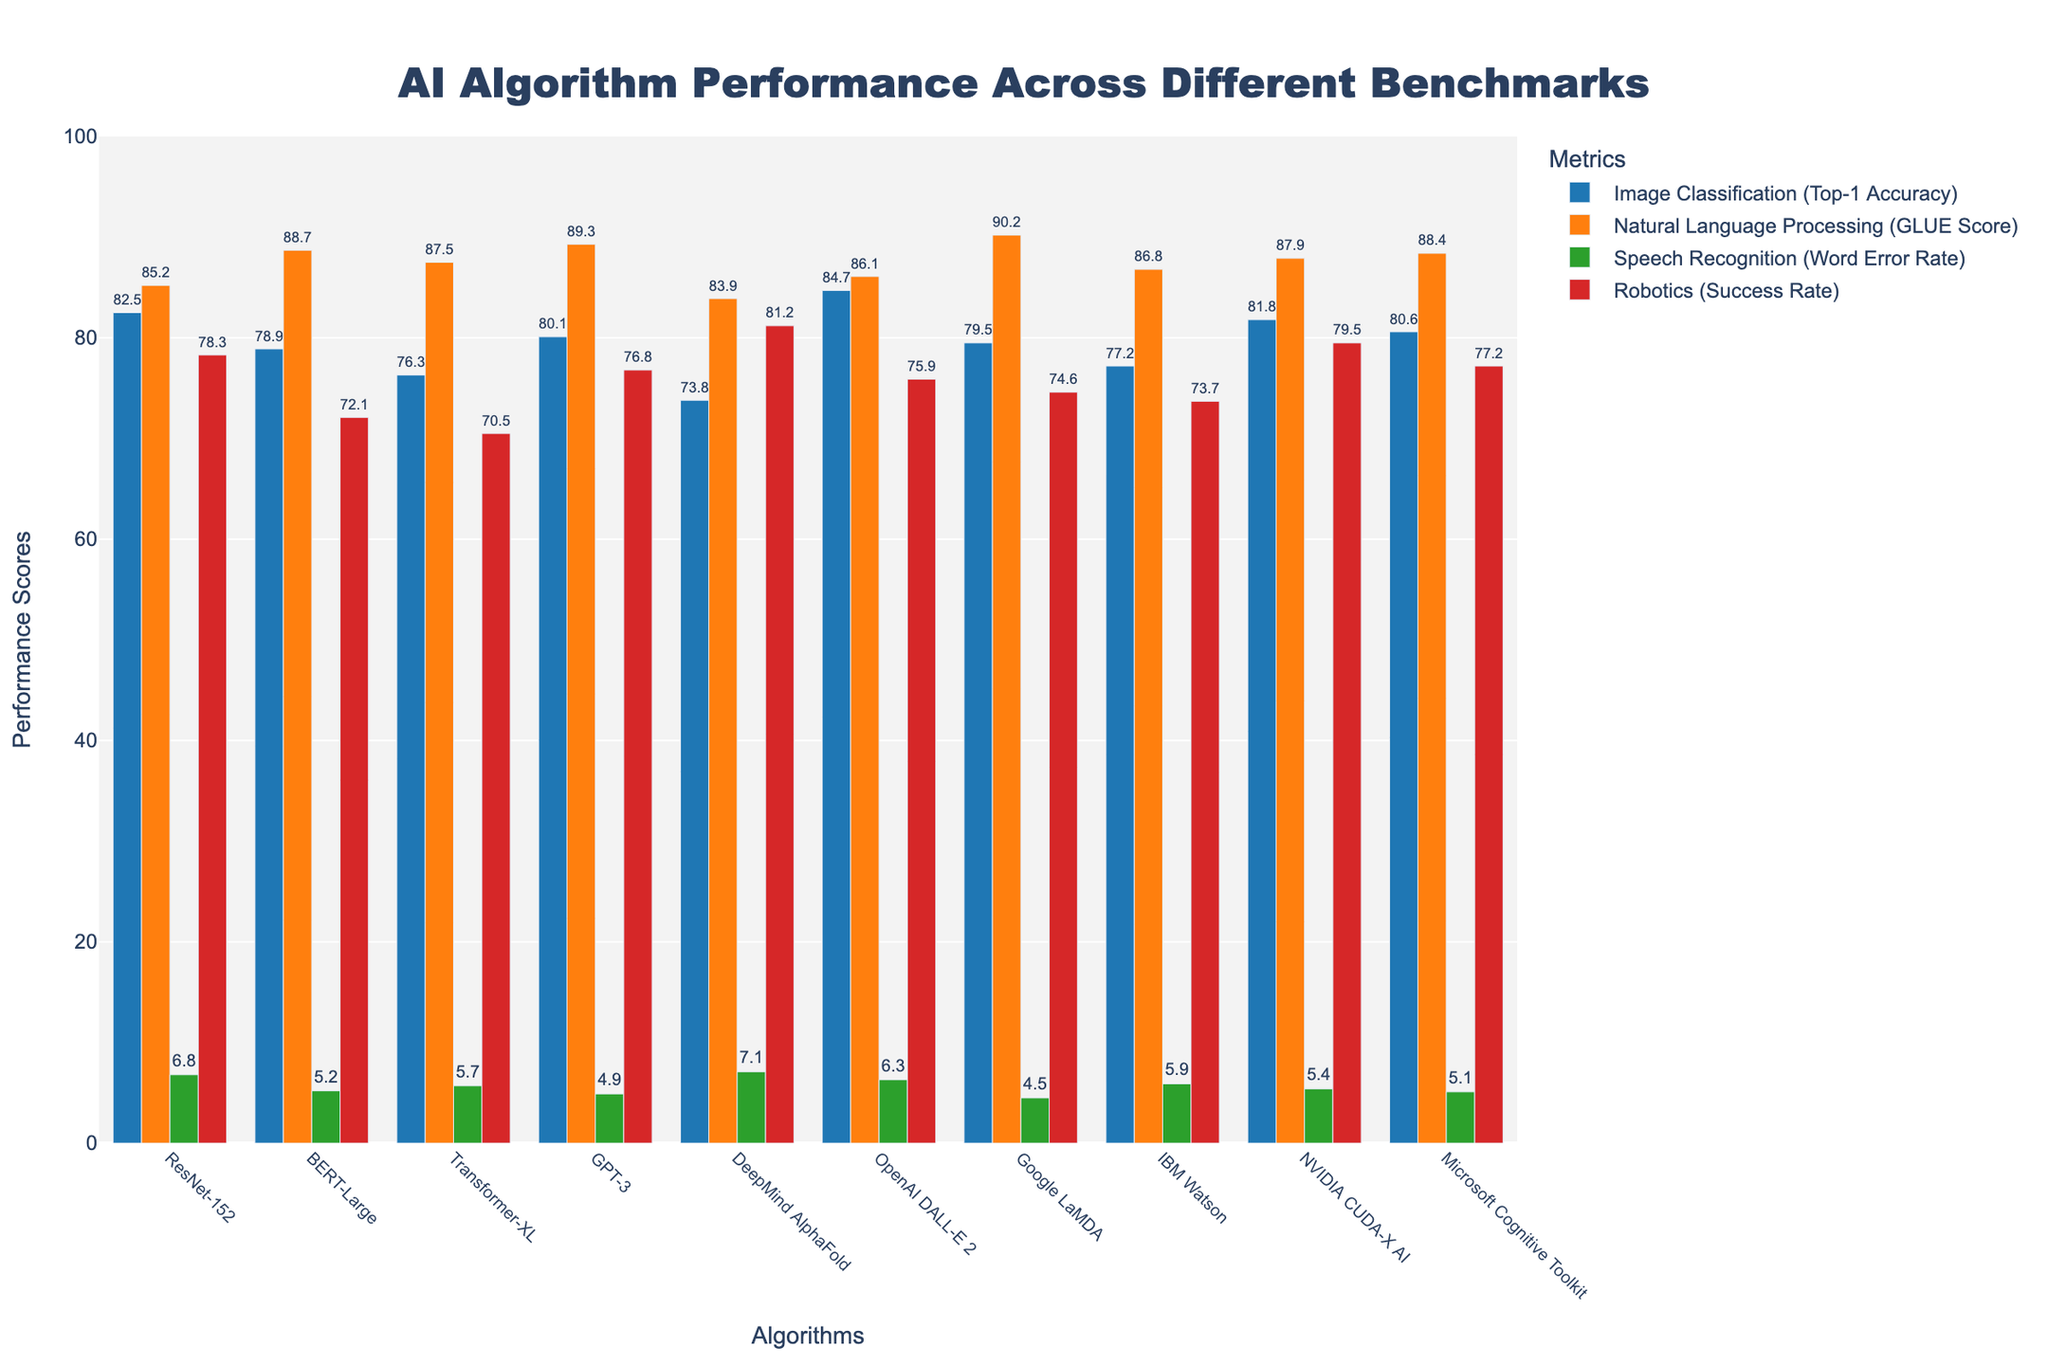What's the difference in Top-1 Accuracy between OpenAI DALL-E 2 and ResNet-152? ResNet-152 has a Top-1 Accuracy of 82.5, and OpenAI DALL-E 2 has 84.7. The difference is 84.7 - 82.5.
Answer: 2.2 Which algorithm has the highest GLUE Score in Natural Language Processing? GLUE Scores are shown for each algorithm, and Google LaMDA has the highest score of 90.2.
Answer: Google LaMDA How does GPT-3 compare to BERT-Large in Speech Recognition (Word Error Rate)? GPT-3 has a Word Error Rate of 4.9, and BERT-Large has 5.2. GPT-3's value is lower, indicating better performance.
Answer: GPT-3 has a lower Word Error Rate What is the average Success Rate in Robotics for all algorithms? Success Rates in Robotics for all algorithms are: 78.3, 72.1, 70.5, 76.8, 81.2, 75.9, 74.6, 73.7, 79.5, 77.2. Sum these values (740.8) and divide by 10.
Answer: 74.1 Compare the performance of Transformer-XL and IBM Watson in Image Classification. Which one performs better? Transformer-XL has a Top-1 Accuracy of 76.3, while IBM Watson has 77.2. IBM Watson performs better.
Answer: IBM Watson Which algorithm shows the lowest Word Error Rate in Speech Recognition? By comparing all Word Error Rates, Google LaMDA has the lowest at 4.5.
Answer: Google LaMDA Is the Top-1 Accuracy of Microsoft Cognitive Toolkit higher or lower than ResNet-152? Microsoft Cognitive Toolkit has a Top-1 Accuracy of 80.6, whereas ResNet-152 has 82.5. The Microsoft Cognitive Toolkit is lower.
Answer: Lower What is the range of Success Rates in Robotics among all algorithms? The maximum Success Rate is 81.2 (DeepMind AlphaFold) and the minimum is 70.5 (Transformer-XL). The range is 81.2 - 70.5.
Answer: 10.7 How much higher is the GLUE Score for Google LaMDA compared to Transformer-XL? Google LaMDA's GLUE Score is 90.2, and Transformer-XL's is 87.5. The difference is 90.2 - 87.5.
Answer: 2.7 Which algorithm has both the highest Top-1 Accuracy and a high GLUE Score? OpenAI DALL-E 2 has the highest Top-1 Accuracy (84.7) and also has a relatively high GLUE Score (86.1).
Answer: OpenAI DALL-E 2 